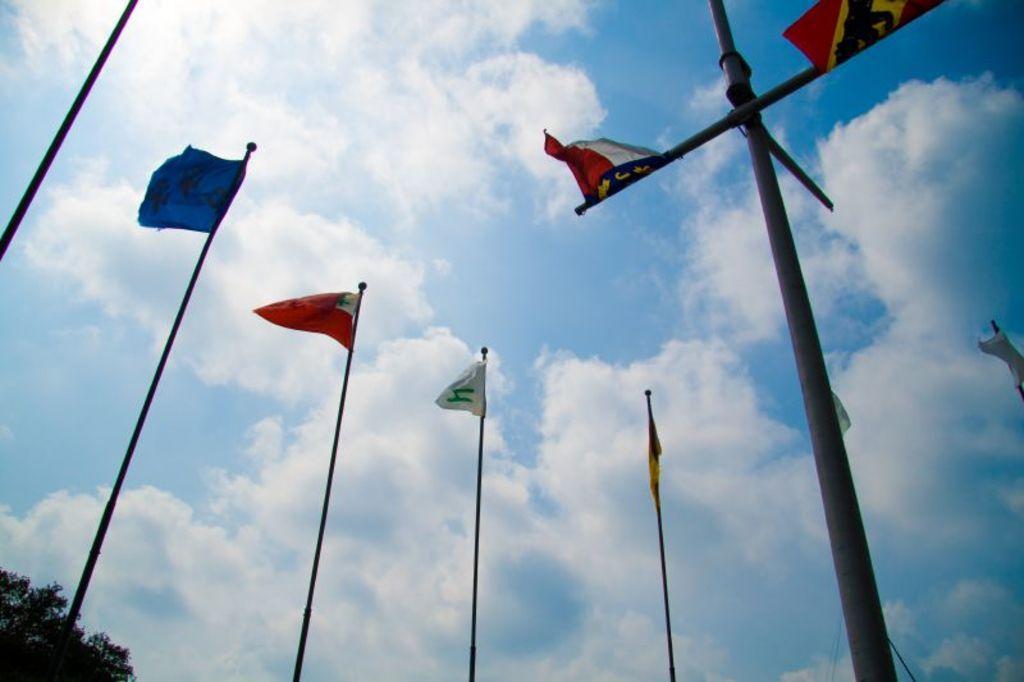Please provide a concise description of this image. In the bottom left corner of the image there is a tree. In the middle of the image there are some poles and flags. Behind them there are some clouds in the sky. 